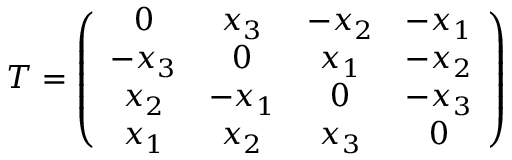Convert formula to latex. <formula><loc_0><loc_0><loc_500><loc_500>T = \left ( \begin{array} { c c c c } { 0 } & { { x _ { 3 } } } & { { - x _ { 2 } } } & { { - x _ { 1 } } } \\ { { - x _ { 3 } } } & { 0 } & { { x _ { 1 } } } & { { - x _ { 2 } } } \\ { { x _ { 2 } } } & { { - x _ { 1 } } } & { 0 } & { { - x _ { 3 } } } \\ { { x _ { 1 } } } & { { x _ { 2 } } } & { { x _ { 3 } } } & { 0 } \end{array} \right )</formula> 